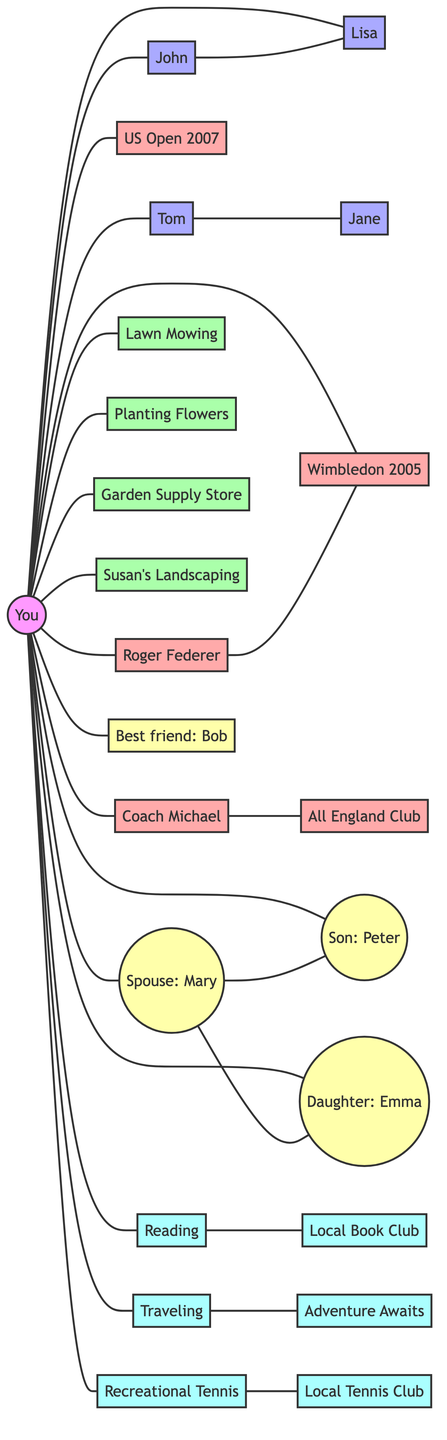What is the total number of nodes in the "Connections and Friendships in the Local Community" section? By counting the distinct entities in the "Connections and Friendships in the Local Community" part of the diagram, I identify five nodes: You, John, Lisa, Tom, and Jane.
Answer: 5 Who is connected to the local grocer? To answer this, I check the connections from You to other nodes. The local grocer is Lisa, and she is directly connected to You and John from the neighborhood.
Answer: You and John What is the main relationship represented between You and Coach Michael? The diagram shows a direct edge/connection from You to Coach Michael, indicating that they have a direct relationship, specifically in the tennis career context.
Answer: Direct connection Which activity is associated with Susan? In the gardening section, I find that the only action connected to Susan is her landscaping services, suggesting she provides gardening help.
Answer: Landscaping Services How many distinct hobbies are listed in the "Leisure Activities and Hobby Connections Map"? I look for the unique hobbies present in that section, revealing three distinct activities: Reading, Traveling, and Recreational Tennis.
Answer: 3 Who is related to both Peter and Emma? By checking the family section, I find that Mary (spouse) is the common node, as she connects to both Peter and Emma, representing a familial relationship.
Answer: Mary Are there any connections between recreational tennis and local businesses? I analyze the connections stemming from Recreational Tennis, noticing it connects to the Local Tennis Club, indicating a link to a local business relevant to this hobby.
Answer: Local Tennis Club What is one seasonal task associated with planting flowers? I extract information pointing to the Fall as the season linked to the task of planting flowers, thereby highlighting its scheduling aspect in gardening.
Answer: Fall Who are Tennis rivals in this network? I identify the relevant connection to tennis rivals from You to Roger Federer, indicating a competitive relationship in the context of a tennis career highlighted in the diagram.
Answer: Roger Federer 